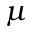Convert formula to latex. <formula><loc_0><loc_0><loc_500><loc_500>\mu</formula> 